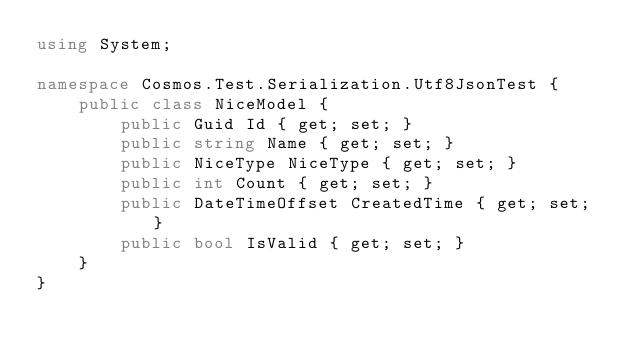Convert code to text. <code><loc_0><loc_0><loc_500><loc_500><_C#_>using System;

namespace Cosmos.Test.Serialization.Utf8JsonTest {
    public class NiceModel {
        public Guid Id { get; set; }
        public string Name { get; set; }
        public NiceType NiceType { get; set; }
        public int Count { get; set; }
        public DateTimeOffset CreatedTime { get; set; }
        public bool IsValid { get; set; }
    }
}</code> 